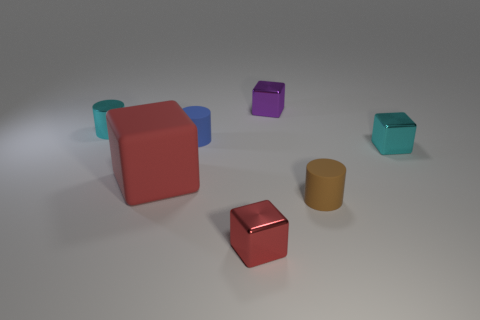There is a blue object that is the same material as the tiny brown thing; what is its shape?
Your answer should be compact. Cylinder. What number of tiny things are to the right of the small purple object and in front of the cyan block?
Provide a short and direct response. 1. Do the tiny object on the left side of the large red block and the metallic object that is to the right of the tiny purple shiny cube have the same color?
Your response must be concise. Yes. The cyan thing that is the same shape as the red rubber object is what size?
Provide a short and direct response. Small. Are there any small cylinders to the left of the tiny red shiny cube?
Your response must be concise. Yes. Are there an equal number of matte things right of the small brown rubber cylinder and big green rubber objects?
Provide a short and direct response. Yes. There is a metal cube that is on the right side of the cylinder that is right of the blue rubber thing; are there any tiny brown rubber things that are right of it?
Keep it short and to the point. No. What is the material of the cyan cube?
Ensure brevity in your answer.  Metal. What number of other objects are there of the same shape as the large matte object?
Your response must be concise. 3. Is the big thing the same shape as the purple thing?
Provide a short and direct response. Yes. 